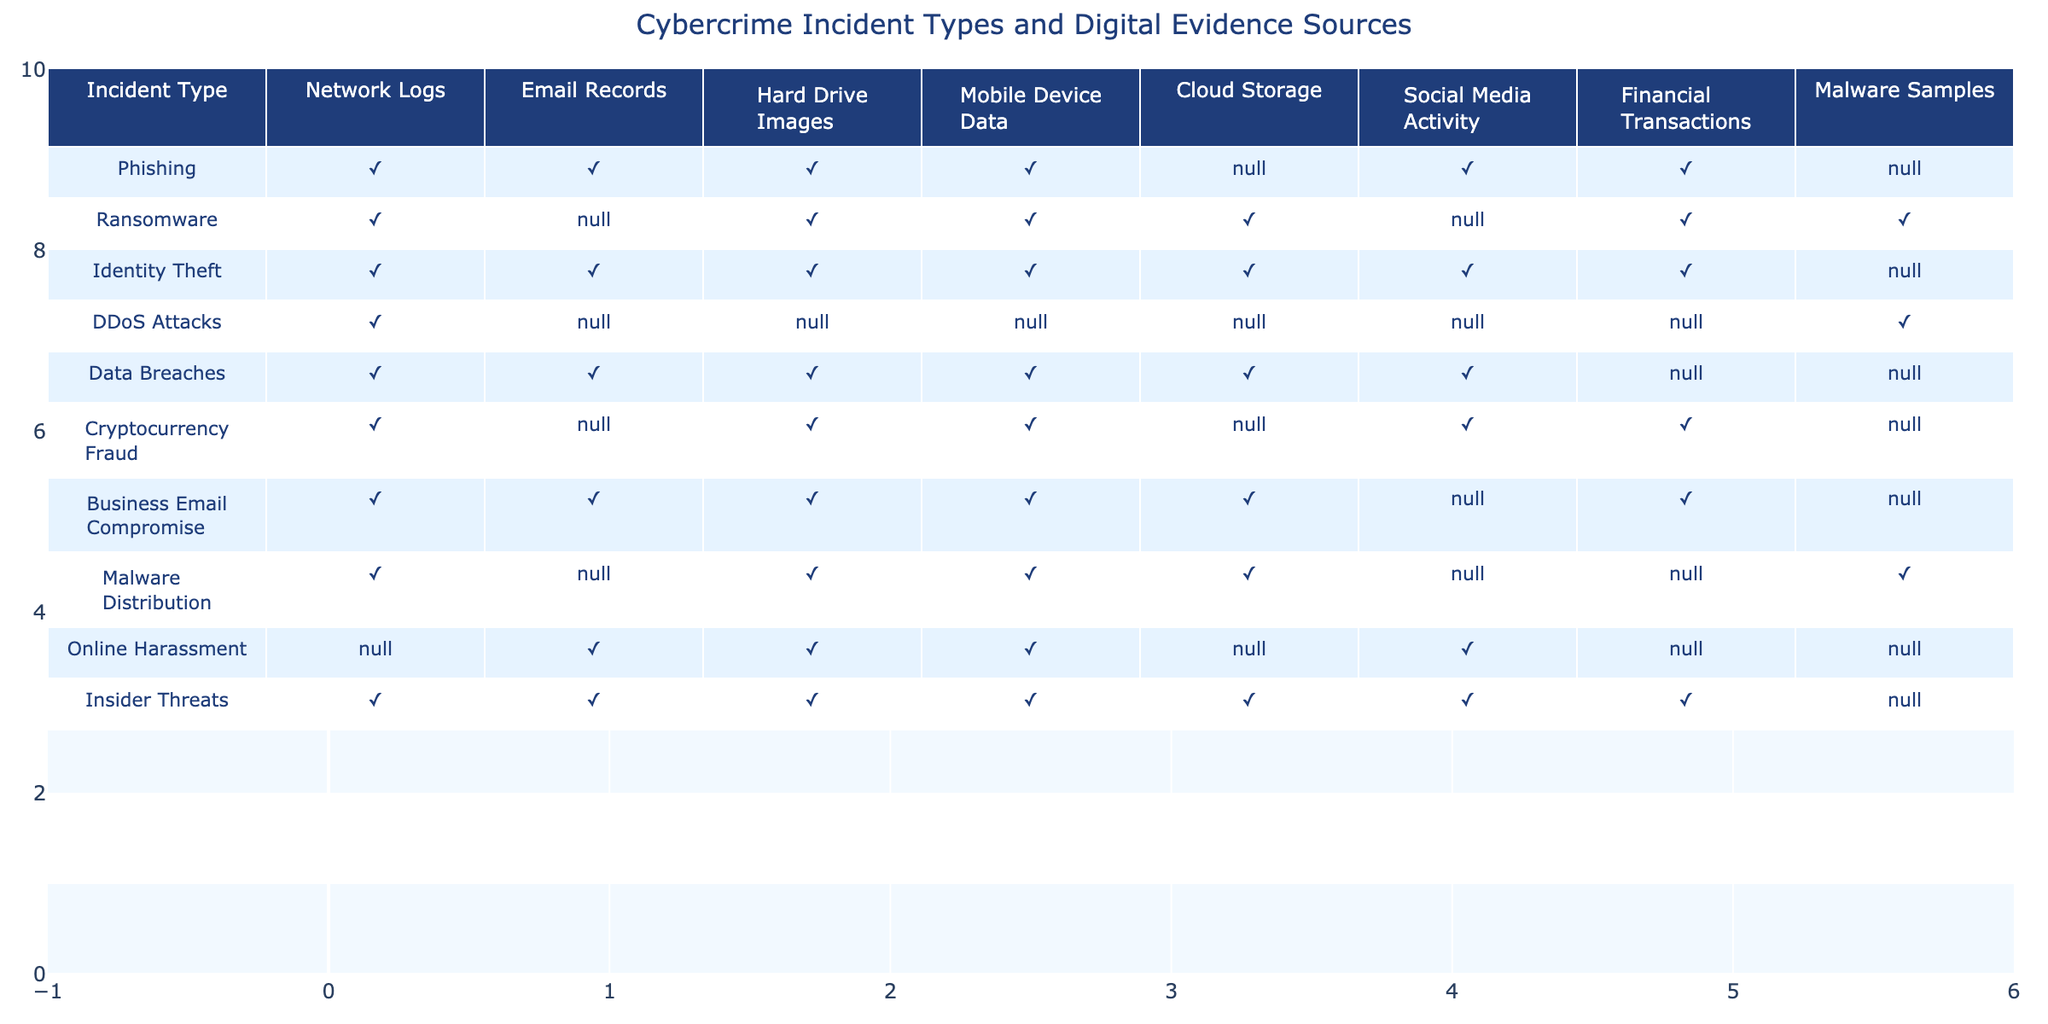What types of incidents involve mobile device data? By examining the table, we can identify the incident types that have a checkmark under the "Mobile Device Data" column. The incident types are Ransomware, Identity Theft, Business Email Compromise, and Malware Distribution.
Answer: Ransomware, Identity Theft, Business Email Compromise, Malware Distribution Are network logs relevant to DDoS attacks? Looking at the table, DDoS attacks have a checkmark under the "Network Logs" column, indicating that network logs are indeed relevant to this type of cybercrime.
Answer: Yes How many incident types have financial transaction data as a source? We analyze the "Financial Transactions" column and count how many incident types have a checkmark. The count reveals that Identity Theft, Cryptocurrency Fraud, Business Email Compromise, Insider Threats, and Malware Distribution all have a checkmark, totaling five incident types.
Answer: Five Is email evidence used for all incident types listed in the table? Checking the "Email Records" column, we find that Online Harassment lacks a checkmark, indicating that email evidence is not used for all incident types.
Answer: No Which incident types might require both hard drive images and cloud storage data? We check the columns for both "Hard Drive Images" and "Cloud Storage." The incident types that have checkmarks in both columns are Ransomware, Identity Theft, Data Breaches, and Business Email Compromise. Therefore, these incident types may require both sources of data.
Answer: Ransomware, Identity Theft, Data Breaches, Business Email Compromise What percentage of incident types listed require social media activity as evidence? There are a total of 10 incident types, and those that require social media activity are Phishing, Identity Theft, Online Harassment, and Insider Threats. To find the percentage, we calculate (4/10) * 100 = 40%.
Answer: 40% Do all types of cyber incidents listed involve at least one form of digital evidence? By reviewing the table, we note that there are no incident types that have no checkmarks at all; all listed incident types involve at least one form of digital evidence.
Answer: Yes Which incident type has the most digital evidence sources available? By looking at the checkmarks in each incident type row, we see that Identity Theft and Insider Threats both have seven sources, making them the incident types with the most evidence sources listed.
Answer: Identity Theft, Insider Threats For which incident types can malware samples be a relevant source? Reviewing the column for "Malware Samples," we find that DDoS Attacks, Malware Distribution, and Insider Threats have checkmarks, indicating that these incident types can reference malware samples.
Answer: DDoS Attacks, Malware Distribution, Insider Threats How many incident types include at least three different types of digital evidence sources? Examining the number of checkmarks in each incident type, we count that Ransomware, Identity Theft, Data Breaches, Business Email Compromise, and Insider Threats all have three or more sources, leading to a total of five incident types.
Answer: Five 